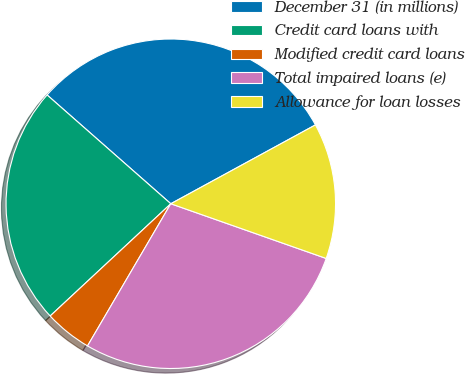Convert chart. <chart><loc_0><loc_0><loc_500><loc_500><pie_chart><fcel>December 31 (in millions)<fcel>Credit card loans with<fcel>Modified credit card loans<fcel>Total impaired loans (e)<fcel>Allowance for loan losses<nl><fcel>30.58%<fcel>23.41%<fcel>4.64%<fcel>28.05%<fcel>13.33%<nl></chart> 